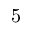<formula> <loc_0><loc_0><loc_500><loc_500>5</formula> 